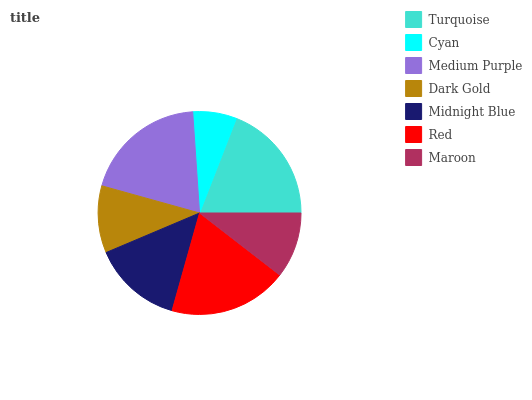Is Cyan the minimum?
Answer yes or no. Yes. Is Medium Purple the maximum?
Answer yes or no. Yes. Is Medium Purple the minimum?
Answer yes or no. No. Is Cyan the maximum?
Answer yes or no. No. Is Medium Purple greater than Cyan?
Answer yes or no. Yes. Is Cyan less than Medium Purple?
Answer yes or no. Yes. Is Cyan greater than Medium Purple?
Answer yes or no. No. Is Medium Purple less than Cyan?
Answer yes or no. No. Is Midnight Blue the high median?
Answer yes or no. Yes. Is Midnight Blue the low median?
Answer yes or no. Yes. Is Cyan the high median?
Answer yes or no. No. Is Cyan the low median?
Answer yes or no. No. 